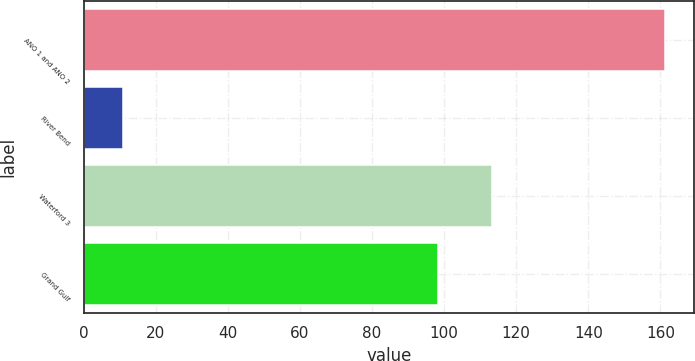<chart> <loc_0><loc_0><loc_500><loc_500><bar_chart><fcel>ANO 1 and ANO 2<fcel>River Bend<fcel>Waterford 3<fcel>Grand Gulf<nl><fcel>161.4<fcel>10.9<fcel>113.35<fcel>98.3<nl></chart> 